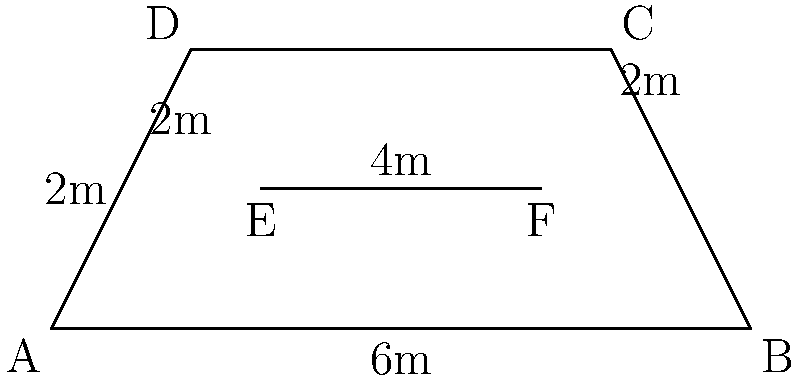During a special screening of Pierce Brosnan's latest film, you notice the movie is projected onto an irregularly shaped screen. The screen resembles a trapezoid with a triangular section on top. Given the dimensions shown in the diagram (in meters), what is the total area of this unique movie screen? To calculate the total area, we'll break down the screen into a trapezoid and a triangle:

1. Area of the trapezoid:
   The formula for a trapezoid's area is $A = \frac{1}{2}(b_1 + b_2)h$
   where $b_1$ and $b_2$ are the parallel sides and $h$ is the height.
   
   $A_{trapezoid} = \frac{1}{2}(6 + 4) \times 2 = \frac{1}{2} \times 10 \times 2 = 10$ m²

2. Area of the triangle:
   The formula for a triangle's area is $A = \frac{1}{2}bh$
   where $b$ is the base and $h$ is the height.
   
   $A_{triangle} = \frac{1}{2} \times 4 \times 2 = 4$ m²

3. Total area:
   $A_{total} = A_{trapezoid} + A_{triangle} = 10 + 4 = 14$ m²

Therefore, the total area of the movie screen is 14 square meters.
Answer: 14 m² 